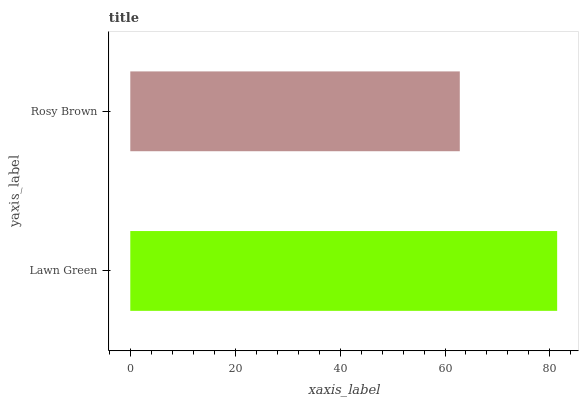Is Rosy Brown the minimum?
Answer yes or no. Yes. Is Lawn Green the maximum?
Answer yes or no. Yes. Is Rosy Brown the maximum?
Answer yes or no. No. Is Lawn Green greater than Rosy Brown?
Answer yes or no. Yes. Is Rosy Brown less than Lawn Green?
Answer yes or no. Yes. Is Rosy Brown greater than Lawn Green?
Answer yes or no. No. Is Lawn Green less than Rosy Brown?
Answer yes or no. No. Is Lawn Green the high median?
Answer yes or no. Yes. Is Rosy Brown the low median?
Answer yes or no. Yes. Is Rosy Brown the high median?
Answer yes or no. No. Is Lawn Green the low median?
Answer yes or no. No. 